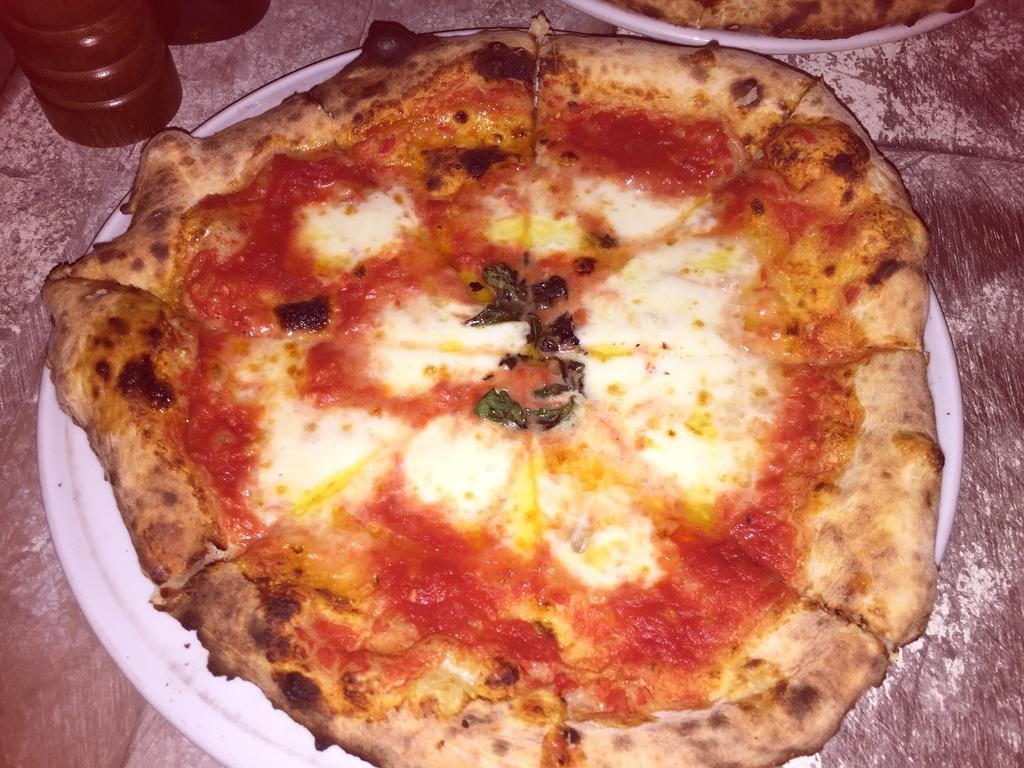In one or two sentences, can you explain what this image depicts? In this picture, we see two plates containing pizzas are placed on the table. Beside that, we see a red color bottle. 